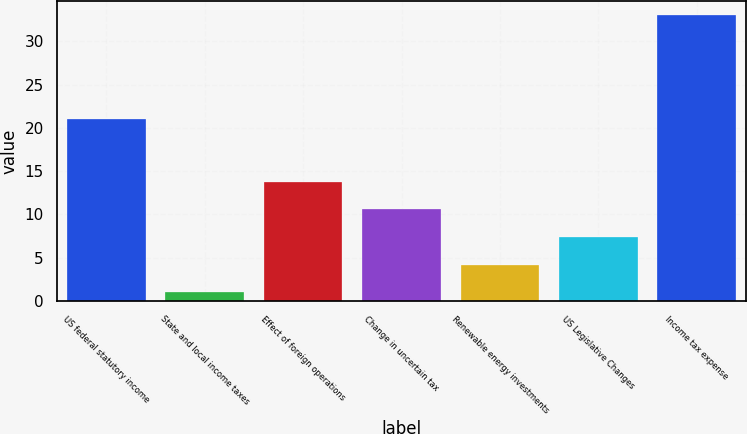Convert chart. <chart><loc_0><loc_0><loc_500><loc_500><bar_chart><fcel>US federal statutory income<fcel>State and local income taxes<fcel>Effect of foreign operations<fcel>Change in uncertain tax<fcel>Renewable energy investments<fcel>US Legislative Changes<fcel>Income tax expense<nl><fcel>21<fcel>1<fcel>13.8<fcel>10.6<fcel>4.2<fcel>7.4<fcel>33<nl></chart> 